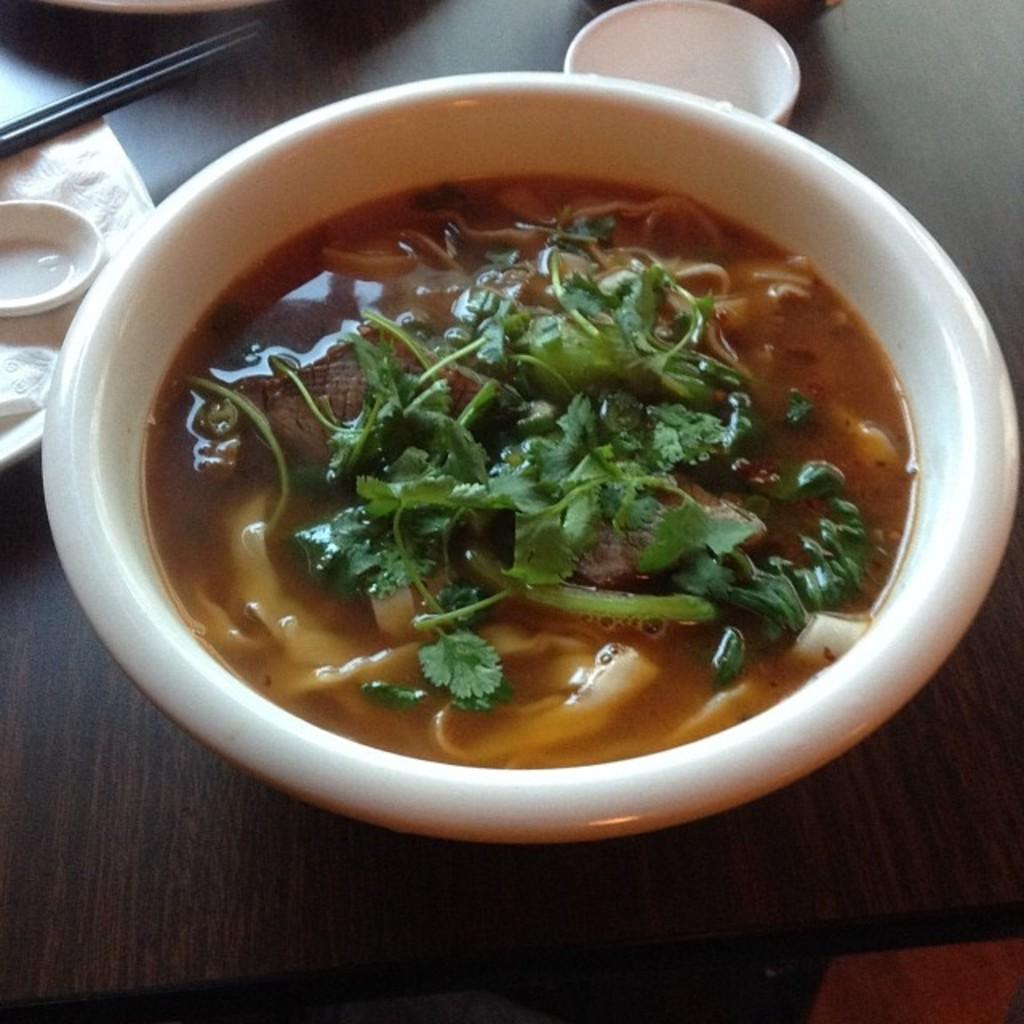What is located in the center of the image? There is a bowl in the center of the image. What is inside the bowl? The bowl contains soap. What type of quilt is being used to cover the bowl of soap in the image? There is no quilt present in the image; it only features a bowl containing soap. 